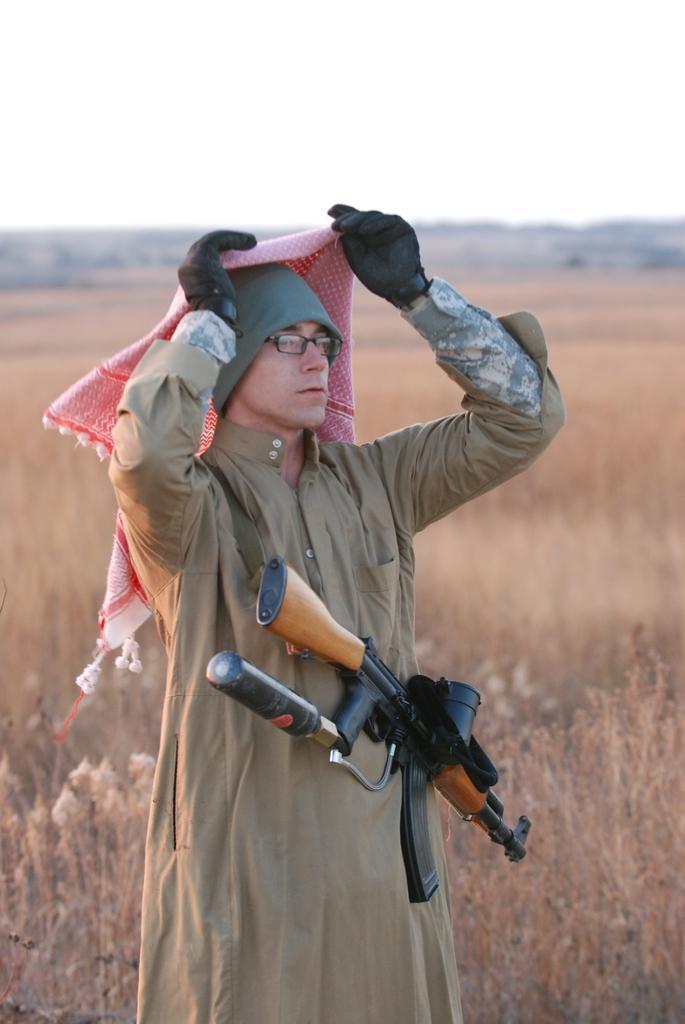Can you describe this image briefly? In this image we can see a man wearing a gun with a belt standing on the ground holding a scarf. We can also see some plants and the sky. 